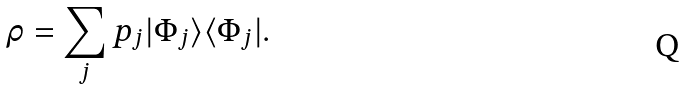<formula> <loc_0><loc_0><loc_500><loc_500>\rho = \sum _ { j } p _ { j } | \Phi _ { j } \rangle \langle \Phi _ { j } | .</formula> 